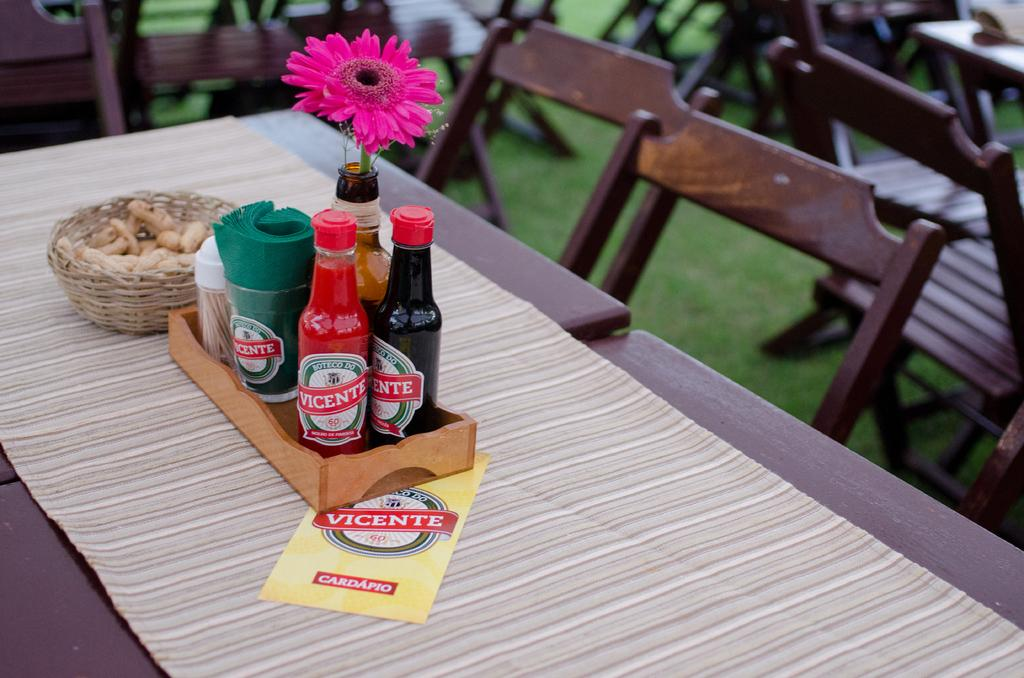Provide a one-sentence caption for the provided image. Several condiments from Vicente sit in a little wooden tray on the table. 